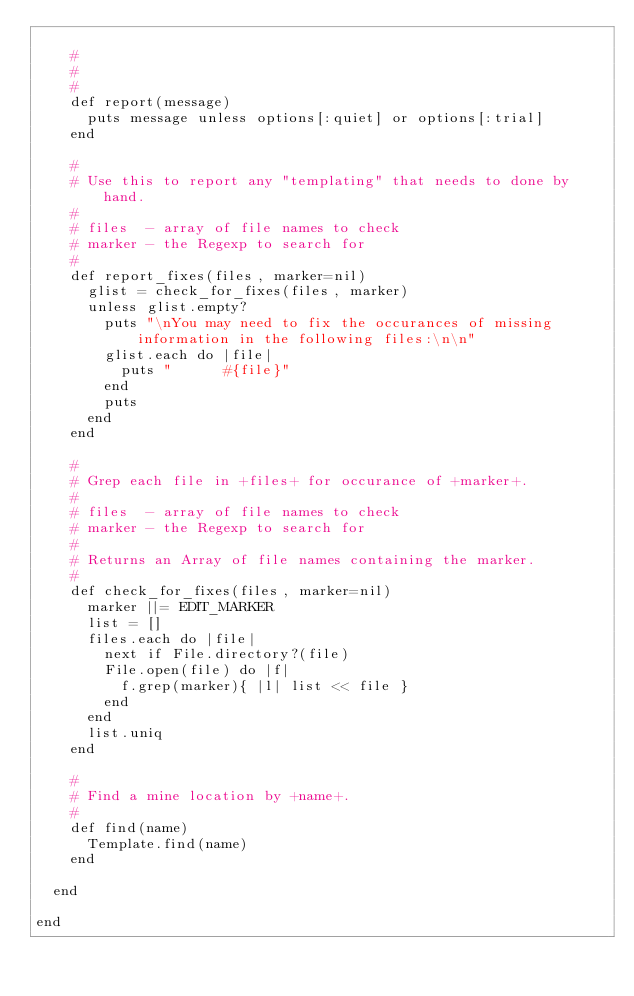<code> <loc_0><loc_0><loc_500><loc_500><_Ruby_>
    #
    #
    #
    def report(message)
      puts message unless options[:quiet] or options[:trial]
    end

    #
    # Use this to report any "templating" that needs to done by hand.
    #
    # files  - array of file names to check
    # marker - the Regexp to search for
    #
    def report_fixes(files, marker=nil)
      glist = check_for_fixes(files, marker)
      unless glist.empty?
        puts "\nYou may need to fix the occurances of missing information in the following files:\n\n"
        glist.each do |file|
          puts "      #{file}"
        end
        puts
      end
    end

    #
    # Grep each file in +files+ for occurance of +marker+.
    #
    # files  - array of file names to check
    # marker - the Regexp to search for
    #
    # Returns an Array of file names containing the marker.
    #
    def check_for_fixes(files, marker=nil)
      marker ||= EDIT_MARKER
      list = []
      files.each do |file|
        next if File.directory?(file)
        File.open(file) do |f|
          f.grep(marker){ |l| list << file }
        end
      end
      list.uniq
    end

    #
    # Find a mine location by +name+.
    #
    def find(name)
      Template.find(name)
    end

  end

end
</code> 